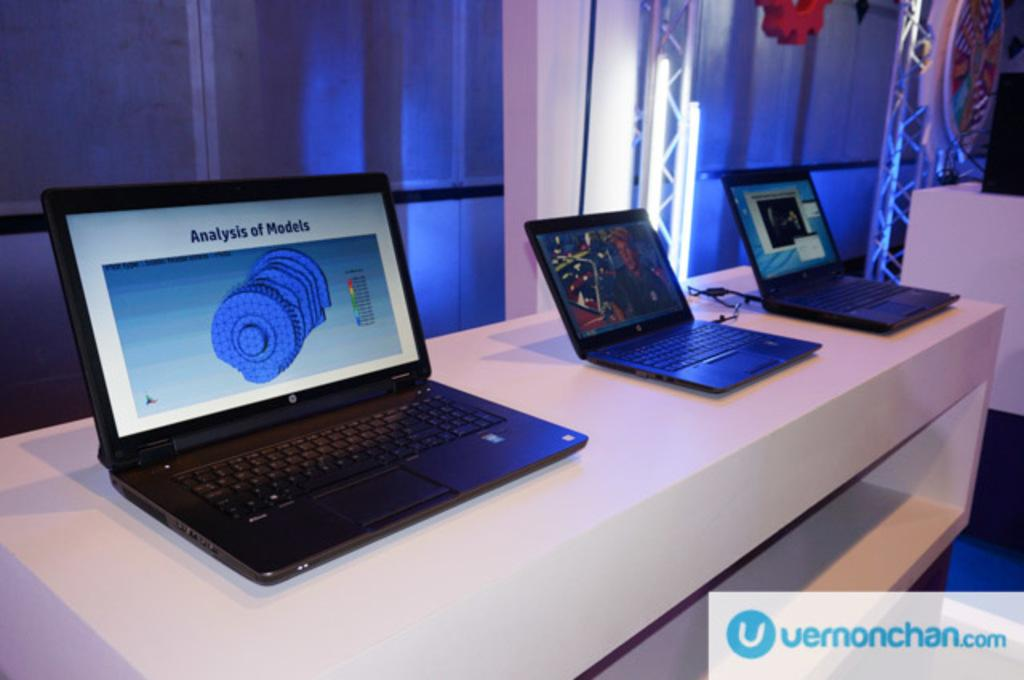<image>
Offer a succinct explanation of the picture presented. Three laptops on a table, one with "Analysis of Models" on the screen. 